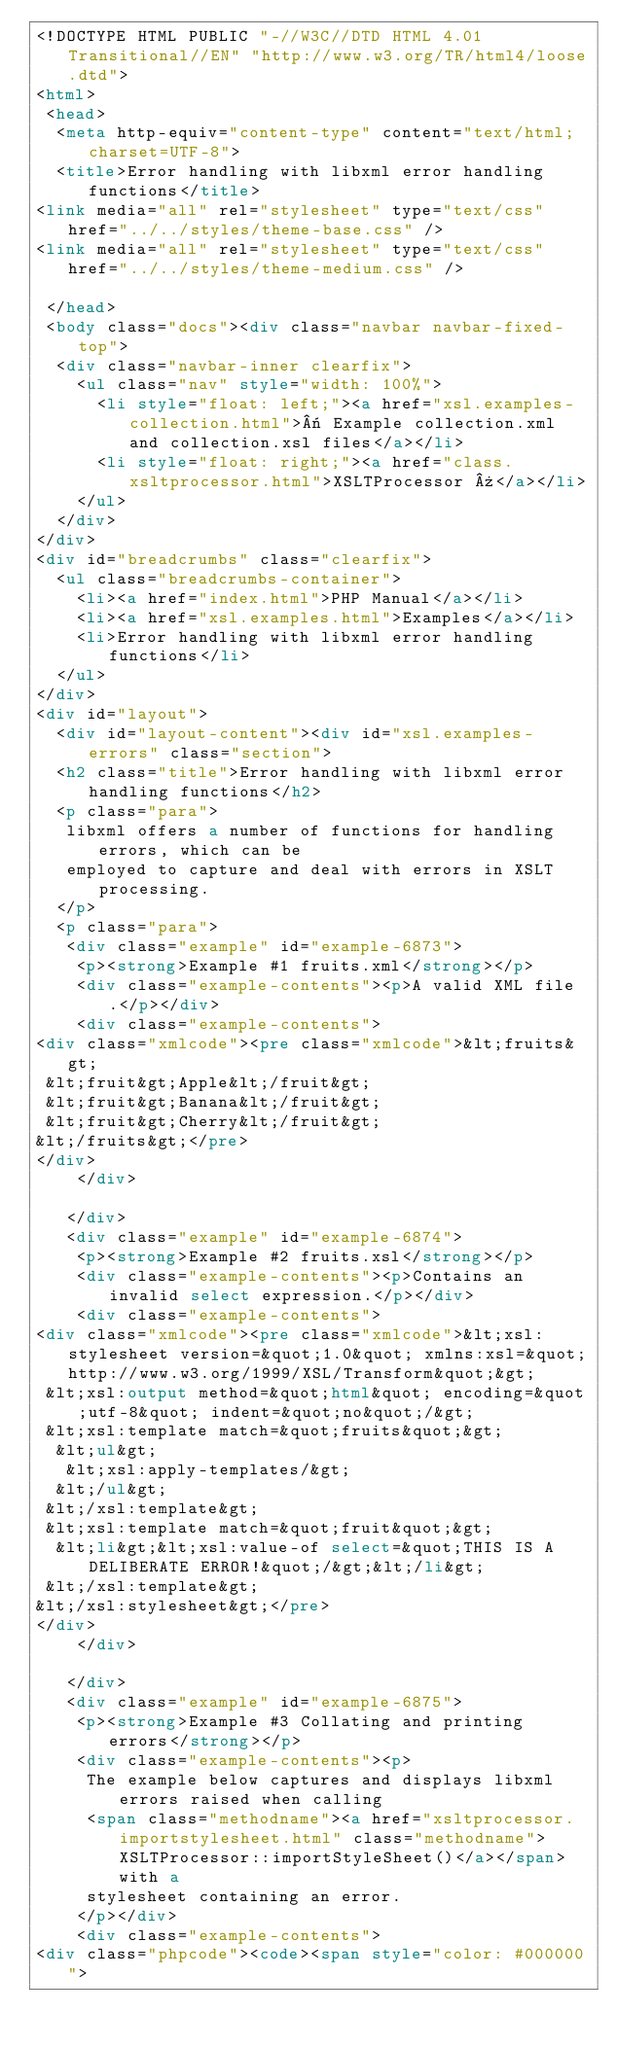<code> <loc_0><loc_0><loc_500><loc_500><_HTML_><!DOCTYPE HTML PUBLIC "-//W3C//DTD HTML 4.01 Transitional//EN" "http://www.w3.org/TR/html4/loose.dtd">
<html>
 <head>
  <meta http-equiv="content-type" content="text/html; charset=UTF-8">
  <title>Error handling with libxml error handling functions</title>
<link media="all" rel="stylesheet" type="text/css" href="../../styles/theme-base.css" />
<link media="all" rel="stylesheet" type="text/css" href="../../styles/theme-medium.css" />

 </head>
 <body class="docs"><div class="navbar navbar-fixed-top">
  <div class="navbar-inner clearfix">
    <ul class="nav" style="width: 100%">
      <li style="float: left;"><a href="xsl.examples-collection.html">« Example collection.xml and collection.xsl files</a></li>
      <li style="float: right;"><a href="class.xsltprocessor.html">XSLTProcessor »</a></li>
    </ul>
  </div>
</div>
<div id="breadcrumbs" class="clearfix">
  <ul class="breadcrumbs-container">
    <li><a href="index.html">PHP Manual</a></li>
    <li><a href="xsl.examples.html">Examples</a></li>
    <li>Error handling with libxml error handling functions</li>
  </ul>
</div>
<div id="layout">
  <div id="layout-content"><div id="xsl.examples-errors" class="section">
  <h2 class="title">Error handling with libxml error handling functions</h2>
  <p class="para">
   libxml offers a number of functions for handling errors, which can be
   employed to capture and deal with errors in XSLT processing.
  </p>
  <p class="para">
   <div class="example" id="example-6873">
    <p><strong>Example #1 fruits.xml</strong></p>
    <div class="example-contents"><p>A valid XML file.</p></div>
    <div class="example-contents">
<div class="xmlcode"><pre class="xmlcode">&lt;fruits&gt;
 &lt;fruit&gt;Apple&lt;/fruit&gt;
 &lt;fruit&gt;Banana&lt;/fruit&gt;
 &lt;fruit&gt;Cherry&lt;/fruit&gt;
&lt;/fruits&gt;</pre>
</div>
    </div>

   </div>
   <div class="example" id="example-6874">
    <p><strong>Example #2 fruits.xsl</strong></p>
    <div class="example-contents"><p>Contains an invalid select expression.</p></div>
    <div class="example-contents">
<div class="xmlcode"><pre class="xmlcode">&lt;xsl:stylesheet version=&quot;1.0&quot; xmlns:xsl=&quot;http://www.w3.org/1999/XSL/Transform&quot;&gt;
 &lt;xsl:output method=&quot;html&quot; encoding=&quot;utf-8&quot; indent=&quot;no&quot;/&gt;
 &lt;xsl:template match=&quot;fruits&quot;&gt;
  &lt;ul&gt;
   &lt;xsl:apply-templates/&gt;
  &lt;/ul&gt;
 &lt;/xsl:template&gt;
 &lt;xsl:template match=&quot;fruit&quot;&gt;
  &lt;li&gt;&lt;xsl:value-of select=&quot;THIS IS A DELIBERATE ERROR!&quot;/&gt;&lt;/li&gt;
 &lt;/xsl:template&gt;
&lt;/xsl:stylesheet&gt;</pre>
</div>
    </div>

   </div>
   <div class="example" id="example-6875">
    <p><strong>Example #3 Collating and printing errors</strong></p>
    <div class="example-contents"><p>
     The example below captures and displays libxml errors raised when calling
     <span class="methodname"><a href="xsltprocessor.importstylesheet.html" class="methodname">XSLTProcessor::importStyleSheet()</a></span> with a
     stylesheet containing an error.
    </p></div>
    <div class="example-contents">
<div class="phpcode"><code><span style="color: #000000"></code> 